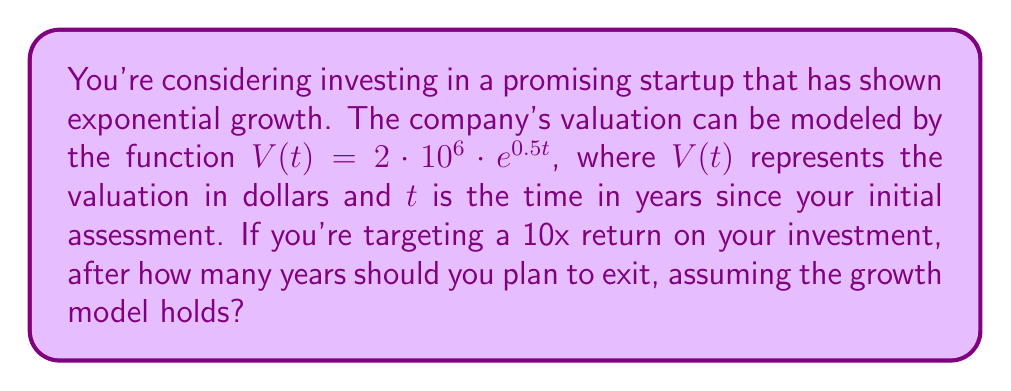Solve this math problem. Let's approach this step-by-step:

1) The initial valuation (at $t=0$) is:
   $V(0) = 2 \cdot 10^6 \cdot e^{0.5 \cdot 0} = 2 \cdot 10^6 = 2,000,000$

2) We want to find $t$ when the valuation is 10 times this initial value:
   $10 \cdot 2,000,000 = 20,000,000$

3) So, we need to solve the equation:
   $20,000,000 = 2 \cdot 10^6 \cdot e^{0.5t}$

4) Simplify:
   $10 = e^{0.5t}$

5) Take natural log of both sides:
   $\ln(10) = \ln(e^{0.5t})$

6) Simplify the right side:
   $\ln(10) = 0.5t$

7) Solve for $t$:
   $t = \frac{\ln(10)}{0.5} = 2 \ln(10) \approx 4.605$

Therefore, you should plan to exit after approximately 4.605 years to achieve a 10x return.
Answer: $2 \ln(10) \approx 4.605$ years 